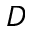<formula> <loc_0><loc_0><loc_500><loc_500>D</formula> 